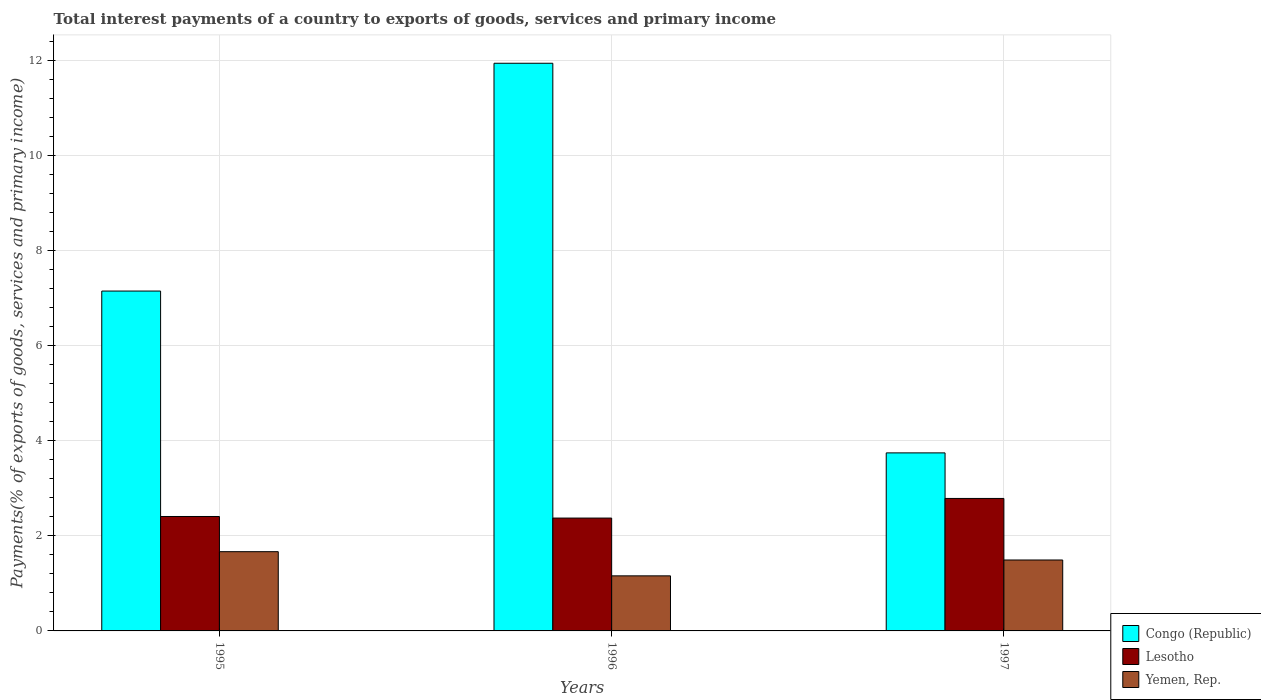How many different coloured bars are there?
Ensure brevity in your answer.  3. Are the number of bars per tick equal to the number of legend labels?
Give a very brief answer. Yes. How many bars are there on the 3rd tick from the right?
Your response must be concise. 3. What is the label of the 3rd group of bars from the left?
Provide a succinct answer. 1997. What is the total interest payments in Lesotho in 1995?
Make the answer very short. 2.41. Across all years, what is the maximum total interest payments in Congo (Republic)?
Offer a terse response. 11.94. Across all years, what is the minimum total interest payments in Lesotho?
Provide a succinct answer. 2.37. What is the total total interest payments in Congo (Republic) in the graph?
Ensure brevity in your answer.  22.83. What is the difference between the total interest payments in Lesotho in 1995 and that in 1996?
Provide a short and direct response. 0.03. What is the difference between the total interest payments in Congo (Republic) in 1996 and the total interest payments in Lesotho in 1995?
Your response must be concise. 9.53. What is the average total interest payments in Congo (Republic) per year?
Your answer should be compact. 7.61. In the year 1996, what is the difference between the total interest payments in Congo (Republic) and total interest payments in Yemen, Rep.?
Keep it short and to the point. 10.78. In how many years, is the total interest payments in Yemen, Rep. greater than 6.8 %?
Provide a short and direct response. 0. What is the ratio of the total interest payments in Congo (Republic) in 1995 to that in 1997?
Offer a terse response. 1.91. What is the difference between the highest and the second highest total interest payments in Yemen, Rep.?
Your answer should be very brief. 0.17. What is the difference between the highest and the lowest total interest payments in Yemen, Rep.?
Ensure brevity in your answer.  0.51. What does the 3rd bar from the left in 1995 represents?
Your answer should be compact. Yemen, Rep. What does the 1st bar from the right in 1995 represents?
Your answer should be compact. Yemen, Rep. Is it the case that in every year, the sum of the total interest payments in Lesotho and total interest payments in Yemen, Rep. is greater than the total interest payments in Congo (Republic)?
Ensure brevity in your answer.  No. How many bars are there?
Keep it short and to the point. 9. How many years are there in the graph?
Your answer should be compact. 3. What is the difference between two consecutive major ticks on the Y-axis?
Ensure brevity in your answer.  2. Does the graph contain any zero values?
Provide a succinct answer. No. Does the graph contain grids?
Provide a short and direct response. Yes. How are the legend labels stacked?
Give a very brief answer. Vertical. What is the title of the graph?
Your answer should be very brief. Total interest payments of a country to exports of goods, services and primary income. What is the label or title of the Y-axis?
Make the answer very short. Payments(% of exports of goods, services and primary income). What is the Payments(% of exports of goods, services and primary income) of Congo (Republic) in 1995?
Provide a short and direct response. 7.15. What is the Payments(% of exports of goods, services and primary income) in Lesotho in 1995?
Keep it short and to the point. 2.41. What is the Payments(% of exports of goods, services and primary income) of Yemen, Rep. in 1995?
Keep it short and to the point. 1.67. What is the Payments(% of exports of goods, services and primary income) of Congo (Republic) in 1996?
Keep it short and to the point. 11.94. What is the Payments(% of exports of goods, services and primary income) in Lesotho in 1996?
Your answer should be very brief. 2.37. What is the Payments(% of exports of goods, services and primary income) in Yemen, Rep. in 1996?
Give a very brief answer. 1.16. What is the Payments(% of exports of goods, services and primary income) in Congo (Republic) in 1997?
Provide a short and direct response. 3.74. What is the Payments(% of exports of goods, services and primary income) in Lesotho in 1997?
Your response must be concise. 2.79. What is the Payments(% of exports of goods, services and primary income) in Yemen, Rep. in 1997?
Provide a short and direct response. 1.49. Across all years, what is the maximum Payments(% of exports of goods, services and primary income) in Congo (Republic)?
Give a very brief answer. 11.94. Across all years, what is the maximum Payments(% of exports of goods, services and primary income) in Lesotho?
Provide a short and direct response. 2.79. Across all years, what is the maximum Payments(% of exports of goods, services and primary income) in Yemen, Rep.?
Give a very brief answer. 1.67. Across all years, what is the minimum Payments(% of exports of goods, services and primary income) in Congo (Republic)?
Make the answer very short. 3.74. Across all years, what is the minimum Payments(% of exports of goods, services and primary income) in Lesotho?
Keep it short and to the point. 2.37. Across all years, what is the minimum Payments(% of exports of goods, services and primary income) in Yemen, Rep.?
Provide a succinct answer. 1.16. What is the total Payments(% of exports of goods, services and primary income) of Congo (Republic) in the graph?
Your answer should be compact. 22.83. What is the total Payments(% of exports of goods, services and primary income) of Lesotho in the graph?
Provide a short and direct response. 7.57. What is the total Payments(% of exports of goods, services and primary income) in Yemen, Rep. in the graph?
Offer a very short reply. 4.32. What is the difference between the Payments(% of exports of goods, services and primary income) of Congo (Republic) in 1995 and that in 1996?
Provide a succinct answer. -4.79. What is the difference between the Payments(% of exports of goods, services and primary income) of Lesotho in 1995 and that in 1996?
Offer a terse response. 0.03. What is the difference between the Payments(% of exports of goods, services and primary income) of Yemen, Rep. in 1995 and that in 1996?
Your answer should be very brief. 0.51. What is the difference between the Payments(% of exports of goods, services and primary income) in Congo (Republic) in 1995 and that in 1997?
Your response must be concise. 3.4. What is the difference between the Payments(% of exports of goods, services and primary income) of Lesotho in 1995 and that in 1997?
Provide a succinct answer. -0.38. What is the difference between the Payments(% of exports of goods, services and primary income) in Yemen, Rep. in 1995 and that in 1997?
Provide a short and direct response. 0.17. What is the difference between the Payments(% of exports of goods, services and primary income) in Congo (Republic) in 1996 and that in 1997?
Provide a succinct answer. 8.19. What is the difference between the Payments(% of exports of goods, services and primary income) in Lesotho in 1996 and that in 1997?
Provide a short and direct response. -0.41. What is the difference between the Payments(% of exports of goods, services and primary income) of Yemen, Rep. in 1996 and that in 1997?
Ensure brevity in your answer.  -0.33. What is the difference between the Payments(% of exports of goods, services and primary income) of Congo (Republic) in 1995 and the Payments(% of exports of goods, services and primary income) of Lesotho in 1996?
Give a very brief answer. 4.77. What is the difference between the Payments(% of exports of goods, services and primary income) in Congo (Republic) in 1995 and the Payments(% of exports of goods, services and primary income) in Yemen, Rep. in 1996?
Your response must be concise. 5.99. What is the difference between the Payments(% of exports of goods, services and primary income) of Lesotho in 1995 and the Payments(% of exports of goods, services and primary income) of Yemen, Rep. in 1996?
Your answer should be compact. 1.25. What is the difference between the Payments(% of exports of goods, services and primary income) of Congo (Republic) in 1995 and the Payments(% of exports of goods, services and primary income) of Lesotho in 1997?
Your answer should be very brief. 4.36. What is the difference between the Payments(% of exports of goods, services and primary income) of Congo (Republic) in 1995 and the Payments(% of exports of goods, services and primary income) of Yemen, Rep. in 1997?
Provide a succinct answer. 5.66. What is the difference between the Payments(% of exports of goods, services and primary income) of Lesotho in 1995 and the Payments(% of exports of goods, services and primary income) of Yemen, Rep. in 1997?
Offer a very short reply. 0.91. What is the difference between the Payments(% of exports of goods, services and primary income) of Congo (Republic) in 1996 and the Payments(% of exports of goods, services and primary income) of Lesotho in 1997?
Ensure brevity in your answer.  9.15. What is the difference between the Payments(% of exports of goods, services and primary income) in Congo (Republic) in 1996 and the Payments(% of exports of goods, services and primary income) in Yemen, Rep. in 1997?
Your answer should be compact. 10.45. What is the difference between the Payments(% of exports of goods, services and primary income) of Lesotho in 1996 and the Payments(% of exports of goods, services and primary income) of Yemen, Rep. in 1997?
Keep it short and to the point. 0.88. What is the average Payments(% of exports of goods, services and primary income) of Congo (Republic) per year?
Your answer should be compact. 7.61. What is the average Payments(% of exports of goods, services and primary income) of Lesotho per year?
Provide a succinct answer. 2.52. What is the average Payments(% of exports of goods, services and primary income) in Yemen, Rep. per year?
Your response must be concise. 1.44. In the year 1995, what is the difference between the Payments(% of exports of goods, services and primary income) in Congo (Republic) and Payments(% of exports of goods, services and primary income) in Lesotho?
Provide a succinct answer. 4.74. In the year 1995, what is the difference between the Payments(% of exports of goods, services and primary income) in Congo (Republic) and Payments(% of exports of goods, services and primary income) in Yemen, Rep.?
Make the answer very short. 5.48. In the year 1995, what is the difference between the Payments(% of exports of goods, services and primary income) of Lesotho and Payments(% of exports of goods, services and primary income) of Yemen, Rep.?
Give a very brief answer. 0.74. In the year 1996, what is the difference between the Payments(% of exports of goods, services and primary income) of Congo (Republic) and Payments(% of exports of goods, services and primary income) of Lesotho?
Provide a short and direct response. 9.56. In the year 1996, what is the difference between the Payments(% of exports of goods, services and primary income) in Congo (Republic) and Payments(% of exports of goods, services and primary income) in Yemen, Rep.?
Offer a very short reply. 10.78. In the year 1996, what is the difference between the Payments(% of exports of goods, services and primary income) in Lesotho and Payments(% of exports of goods, services and primary income) in Yemen, Rep.?
Provide a succinct answer. 1.22. In the year 1997, what is the difference between the Payments(% of exports of goods, services and primary income) of Congo (Republic) and Payments(% of exports of goods, services and primary income) of Lesotho?
Your answer should be very brief. 0.96. In the year 1997, what is the difference between the Payments(% of exports of goods, services and primary income) of Congo (Republic) and Payments(% of exports of goods, services and primary income) of Yemen, Rep.?
Keep it short and to the point. 2.25. In the year 1997, what is the difference between the Payments(% of exports of goods, services and primary income) in Lesotho and Payments(% of exports of goods, services and primary income) in Yemen, Rep.?
Ensure brevity in your answer.  1.29. What is the ratio of the Payments(% of exports of goods, services and primary income) in Congo (Republic) in 1995 to that in 1996?
Your answer should be compact. 0.6. What is the ratio of the Payments(% of exports of goods, services and primary income) in Lesotho in 1995 to that in 1996?
Your answer should be very brief. 1.01. What is the ratio of the Payments(% of exports of goods, services and primary income) of Yemen, Rep. in 1995 to that in 1996?
Make the answer very short. 1.44. What is the ratio of the Payments(% of exports of goods, services and primary income) of Congo (Republic) in 1995 to that in 1997?
Ensure brevity in your answer.  1.91. What is the ratio of the Payments(% of exports of goods, services and primary income) of Lesotho in 1995 to that in 1997?
Your response must be concise. 0.86. What is the ratio of the Payments(% of exports of goods, services and primary income) of Yemen, Rep. in 1995 to that in 1997?
Ensure brevity in your answer.  1.12. What is the ratio of the Payments(% of exports of goods, services and primary income) in Congo (Republic) in 1996 to that in 1997?
Make the answer very short. 3.19. What is the ratio of the Payments(% of exports of goods, services and primary income) of Lesotho in 1996 to that in 1997?
Your answer should be compact. 0.85. What is the ratio of the Payments(% of exports of goods, services and primary income) of Yemen, Rep. in 1996 to that in 1997?
Offer a very short reply. 0.78. What is the difference between the highest and the second highest Payments(% of exports of goods, services and primary income) of Congo (Republic)?
Give a very brief answer. 4.79. What is the difference between the highest and the second highest Payments(% of exports of goods, services and primary income) in Lesotho?
Offer a terse response. 0.38. What is the difference between the highest and the second highest Payments(% of exports of goods, services and primary income) in Yemen, Rep.?
Provide a succinct answer. 0.17. What is the difference between the highest and the lowest Payments(% of exports of goods, services and primary income) of Congo (Republic)?
Your answer should be very brief. 8.19. What is the difference between the highest and the lowest Payments(% of exports of goods, services and primary income) in Lesotho?
Offer a terse response. 0.41. What is the difference between the highest and the lowest Payments(% of exports of goods, services and primary income) in Yemen, Rep.?
Your answer should be very brief. 0.51. 